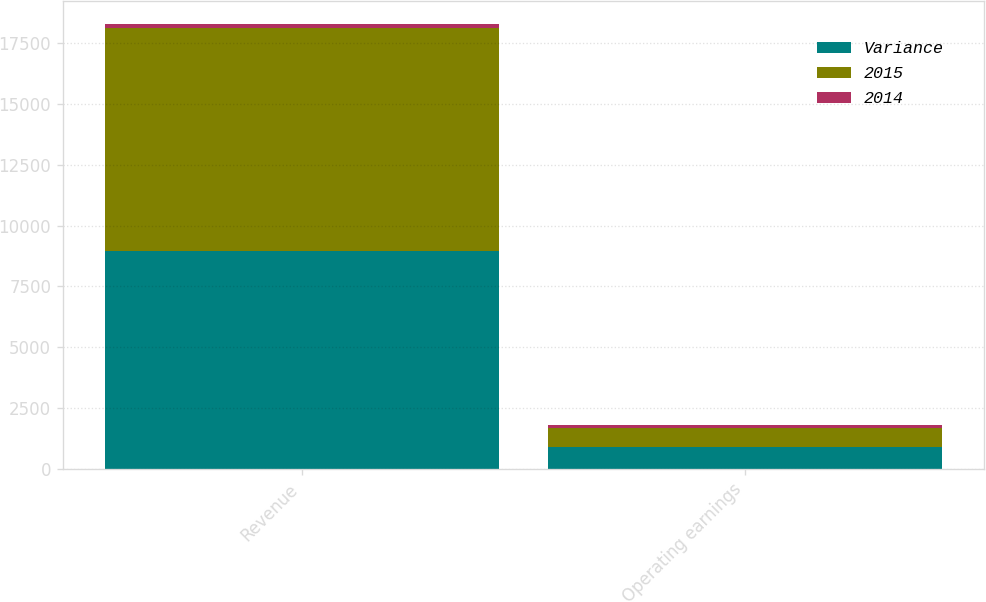Convert chart to OTSL. <chart><loc_0><loc_0><loc_500><loc_500><stacked_bar_chart><ecel><fcel>Revenue<fcel>Operating earnings<nl><fcel>Variance<fcel>8965<fcel>903<nl><fcel>2015<fcel>9159<fcel>785<nl><fcel>2014<fcel>194<fcel>118<nl></chart> 